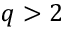<formula> <loc_0><loc_0><loc_500><loc_500>q > 2</formula> 